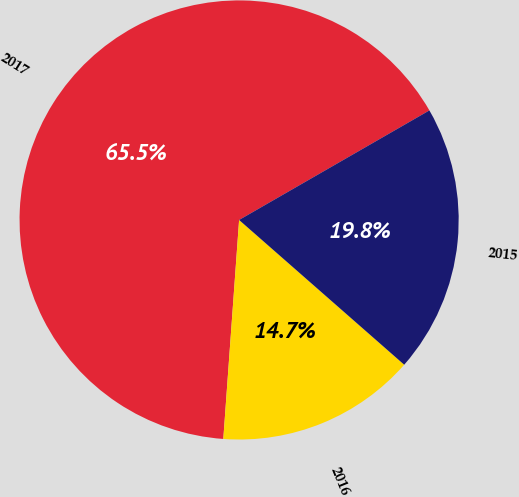Convert chart to OTSL. <chart><loc_0><loc_0><loc_500><loc_500><pie_chart><fcel>2017<fcel>2016<fcel>2015<nl><fcel>65.54%<fcel>14.69%<fcel>19.77%<nl></chart> 